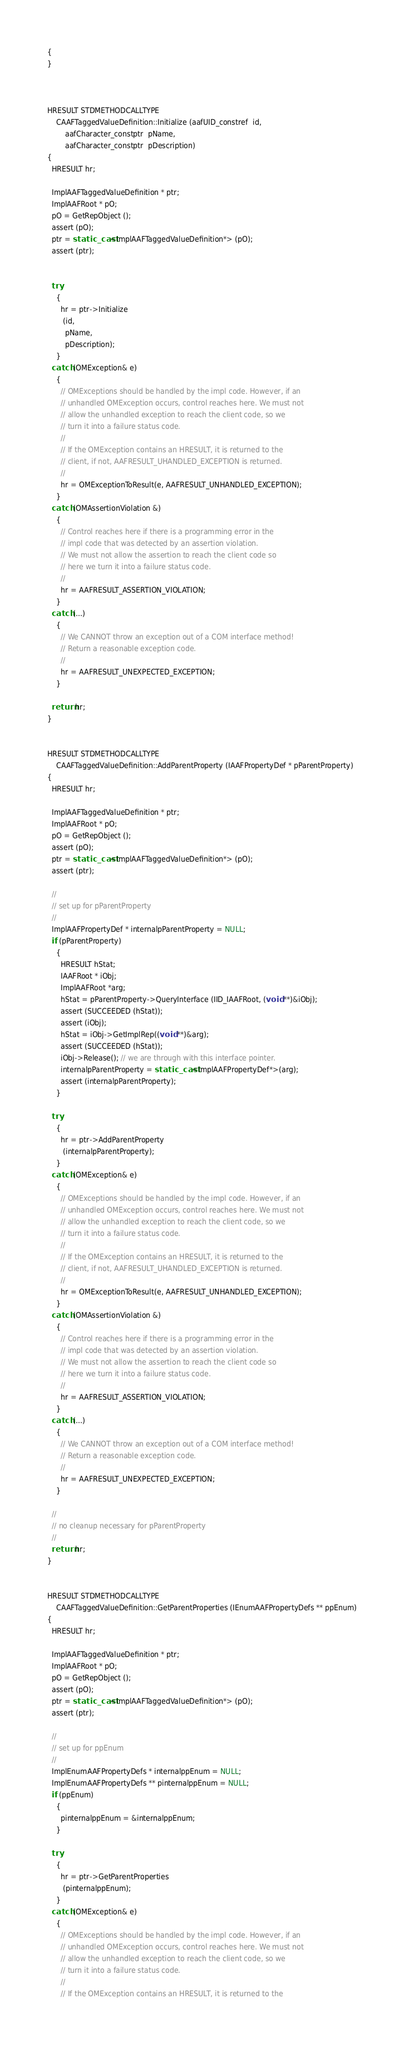Convert code to text. <code><loc_0><loc_0><loc_500><loc_500><_C++_>{
}



HRESULT STDMETHODCALLTYPE
    CAAFTaggedValueDefinition::Initialize (aafUID_constref  id,
        aafCharacter_constptr  pName,
        aafCharacter_constptr  pDescription)
{
  HRESULT hr;

  ImplAAFTaggedValueDefinition * ptr;
  ImplAAFRoot * pO;
  pO = GetRepObject ();
  assert (pO);
  ptr = static_cast<ImplAAFTaggedValueDefinition*> (pO);
  assert (ptr);


  try
    {
      hr = ptr->Initialize
       (id,
        pName,
        pDescription);
    }
  catch (OMException& e)
    {
      // OMExceptions should be handled by the impl code. However, if an
      // unhandled OMException occurs, control reaches here. We must not
      // allow the unhandled exception to reach the client code, so we
      // turn it into a failure status code.
      //
      // If the OMException contains an HRESULT, it is returned to the
      // client, if not, AAFRESULT_UHANDLED_EXCEPTION is returned.
      //
      hr = OMExceptionToResult(e, AAFRESULT_UNHANDLED_EXCEPTION);
    }
  catch (OMAssertionViolation &)
    {
      // Control reaches here if there is a programming error in the
      // impl code that was detected by an assertion violation.
      // We must not allow the assertion to reach the client code so
      // here we turn it into a failure status code.
      //
      hr = AAFRESULT_ASSERTION_VIOLATION;
    }
  catch (...)
    {
      // We CANNOT throw an exception out of a COM interface method!
      // Return a reasonable exception code.
      //
      hr = AAFRESULT_UNEXPECTED_EXCEPTION;
    }

  return hr;
}


HRESULT STDMETHODCALLTYPE
    CAAFTaggedValueDefinition::AddParentProperty (IAAFPropertyDef * pParentProperty)
{
  HRESULT hr;

  ImplAAFTaggedValueDefinition * ptr;
  ImplAAFRoot * pO;
  pO = GetRepObject ();
  assert (pO);
  ptr = static_cast<ImplAAFTaggedValueDefinition*> (pO);
  assert (ptr);

  //
  // set up for pParentProperty
  //
  ImplAAFPropertyDef * internalpParentProperty = NULL;
  if (pParentProperty)
    {
      HRESULT hStat;
      IAAFRoot * iObj;
      ImplAAFRoot *arg;
      hStat = pParentProperty->QueryInterface (IID_IAAFRoot, (void **)&iObj);
      assert (SUCCEEDED (hStat));
      assert (iObj);
      hStat = iObj->GetImplRep((void **)&arg);
      assert (SUCCEEDED (hStat));
      iObj->Release(); // we are through with this interface pointer.
      internalpParentProperty = static_cast<ImplAAFPropertyDef*>(arg);
      assert (internalpParentProperty);
    }

  try
    {
      hr = ptr->AddParentProperty
       (internalpParentProperty);
    }
  catch (OMException& e)
    {
      // OMExceptions should be handled by the impl code. However, if an
      // unhandled OMException occurs, control reaches here. We must not
      // allow the unhandled exception to reach the client code, so we
      // turn it into a failure status code.
      //
      // If the OMException contains an HRESULT, it is returned to the
      // client, if not, AAFRESULT_UHANDLED_EXCEPTION is returned.
      //
      hr = OMExceptionToResult(e, AAFRESULT_UNHANDLED_EXCEPTION);
    }
  catch (OMAssertionViolation &)
    {
      // Control reaches here if there is a programming error in the
      // impl code that was detected by an assertion violation.
      // We must not allow the assertion to reach the client code so
      // here we turn it into a failure status code.
      //
      hr = AAFRESULT_ASSERTION_VIOLATION;
    }
  catch (...)
    {
      // We CANNOT throw an exception out of a COM interface method!
      // Return a reasonable exception code.
      //
      hr = AAFRESULT_UNEXPECTED_EXCEPTION;
    }

  //
  // no cleanup necessary for pParentProperty
  //
  return hr;
}


HRESULT STDMETHODCALLTYPE
    CAAFTaggedValueDefinition::GetParentProperties (IEnumAAFPropertyDefs ** ppEnum)
{
  HRESULT hr;

  ImplAAFTaggedValueDefinition * ptr;
  ImplAAFRoot * pO;
  pO = GetRepObject ();
  assert (pO);
  ptr = static_cast<ImplAAFTaggedValueDefinition*> (pO);
  assert (ptr);

  //
  // set up for ppEnum
  //
  ImplEnumAAFPropertyDefs * internalppEnum = NULL;
  ImplEnumAAFPropertyDefs ** pinternalppEnum = NULL;
  if (ppEnum)
    {
      pinternalppEnum = &internalppEnum;
    }

  try
    {
      hr = ptr->GetParentProperties
       (pinternalppEnum);
    }
  catch (OMException& e)
    {
      // OMExceptions should be handled by the impl code. However, if an
      // unhandled OMException occurs, control reaches here. We must not
      // allow the unhandled exception to reach the client code, so we
      // turn it into a failure status code.
      //
      // If the OMException contains an HRESULT, it is returned to the</code> 